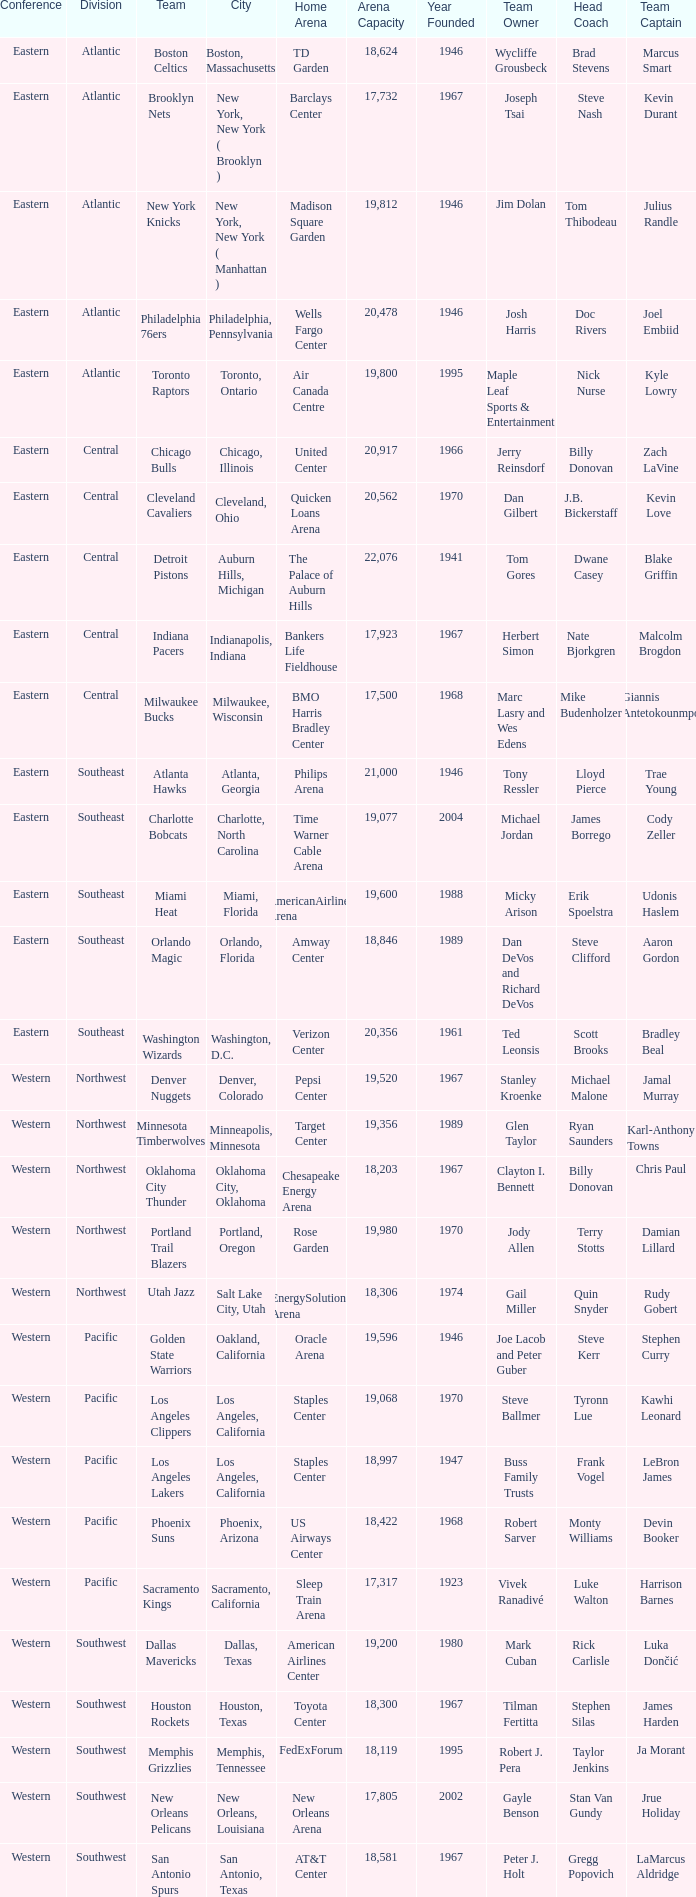Which team is in the Southeast with a home at Philips Arena? Atlanta Hawks. Can you parse all the data within this table? {'header': ['Conference', 'Division', 'Team', 'City', 'Home Arena', 'Arena Capacity', 'Year Founded', 'Team Owner', 'Head Coach', 'Team Captain'], 'rows': [['Eastern', 'Atlantic', 'Boston Celtics', 'Boston, Massachusetts', 'TD Garden', '18,624', '1946', 'Wycliffe Grousbeck', 'Brad Stevens', 'Marcus Smart'], ['Eastern', 'Atlantic', 'Brooklyn Nets', 'New York, New York ( Brooklyn )', 'Barclays Center', '17,732', '1967', 'Joseph Tsai', 'Steve Nash', 'Kevin Durant'], ['Eastern', 'Atlantic', 'New York Knicks', 'New York, New York ( Manhattan )', 'Madison Square Garden', '19,812', '1946', 'Jim Dolan', 'Tom Thibodeau', 'Julius Randle'], ['Eastern', 'Atlantic', 'Philadelphia 76ers', 'Philadelphia, Pennsylvania', 'Wells Fargo Center', '20,478', '1946', 'Josh Harris', 'Doc Rivers', 'Joel Embiid'], ['Eastern', 'Atlantic', 'Toronto Raptors', 'Toronto, Ontario', 'Air Canada Centre', '19,800', '1995', 'Maple Leaf Sports & Entertainment', 'Nick Nurse', 'Kyle Lowry'], ['Eastern', 'Central', 'Chicago Bulls', 'Chicago, Illinois', 'United Center', '20,917', '1966', 'Jerry Reinsdorf', 'Billy Donovan', 'Zach LaVine'], ['Eastern', 'Central', 'Cleveland Cavaliers', 'Cleveland, Ohio', 'Quicken Loans Arena', '20,562', '1970', 'Dan Gilbert', 'J.B. Bickerstaff', 'Kevin Love'], ['Eastern', 'Central', 'Detroit Pistons', 'Auburn Hills, Michigan', 'The Palace of Auburn Hills', '22,076', '1941', 'Tom Gores', 'Dwane Casey', 'Blake Griffin'], ['Eastern', 'Central', 'Indiana Pacers', 'Indianapolis, Indiana', 'Bankers Life Fieldhouse', '17,923', '1967', 'Herbert Simon', 'Nate Bjorkgren', 'Malcolm Brogdon'], ['Eastern', 'Central', 'Milwaukee Bucks', 'Milwaukee, Wisconsin', 'BMO Harris Bradley Center', '17,500', '1968', 'Marc Lasry and Wes Edens', 'Mike Budenholzer', 'Giannis Antetokounmpo'], ['Eastern', 'Southeast', 'Atlanta Hawks', 'Atlanta, Georgia', 'Philips Arena', '21,000', '1946', 'Tony Ressler', 'Lloyd Pierce', 'Trae Young'], ['Eastern', 'Southeast', 'Charlotte Bobcats', 'Charlotte, North Carolina', 'Time Warner Cable Arena', '19,077', '2004', 'Michael Jordan', 'James Borrego', 'Cody Zeller'], ['Eastern', 'Southeast', 'Miami Heat', 'Miami, Florida', 'AmericanAirlines Arena', '19,600', '1988', 'Micky Arison', 'Erik Spoelstra', 'Udonis Haslem'], ['Eastern', 'Southeast', 'Orlando Magic', 'Orlando, Florida', 'Amway Center', '18,846', '1989', 'Dan DeVos and Richard DeVos', 'Steve Clifford', 'Aaron Gordon'], ['Eastern', 'Southeast', 'Washington Wizards', 'Washington, D.C.', 'Verizon Center', '20,356', '1961', 'Ted Leonsis', 'Scott Brooks', 'Bradley Beal'], ['Western', 'Northwest', 'Denver Nuggets', 'Denver, Colorado', 'Pepsi Center', '19,520', '1967', 'Stanley Kroenke', 'Michael Malone', 'Jamal Murray'], ['Western', 'Northwest', 'Minnesota Timberwolves', 'Minneapolis, Minnesota', 'Target Center', '19,356', '1989', 'Glen Taylor', 'Ryan Saunders', 'Karl-Anthony Towns'], ['Western', 'Northwest', 'Oklahoma City Thunder', 'Oklahoma City, Oklahoma', 'Chesapeake Energy Arena', '18,203', '1967', 'Clayton I. Bennett', 'Billy Donovan', 'Chris Paul'], ['Western', 'Northwest', 'Portland Trail Blazers', 'Portland, Oregon', 'Rose Garden', '19,980', '1970', 'Jody Allen', 'Terry Stotts', 'Damian Lillard'], ['Western', 'Northwest', 'Utah Jazz', 'Salt Lake City, Utah', 'EnergySolutions Arena', '18,306', '1974', 'Gail Miller', 'Quin Snyder', 'Rudy Gobert'], ['Western', 'Pacific', 'Golden State Warriors', 'Oakland, California', 'Oracle Arena', '19,596', '1946', 'Joe Lacob and Peter Guber', 'Steve Kerr', 'Stephen Curry'], ['Western', 'Pacific', 'Los Angeles Clippers', 'Los Angeles, California', 'Staples Center', '19,068', '1970', 'Steve Ballmer', 'Tyronn Lue', 'Kawhi Leonard'], ['Western', 'Pacific', 'Los Angeles Lakers', 'Los Angeles, California', 'Staples Center', '18,997', '1947', 'Buss Family Trusts', 'Frank Vogel', 'LeBron James'], ['Western', 'Pacific', 'Phoenix Suns', 'Phoenix, Arizona', 'US Airways Center', '18,422', '1968', 'Robert Sarver', 'Monty Williams', 'Devin Booker'], ['Western', 'Pacific', 'Sacramento Kings', 'Sacramento, California', 'Sleep Train Arena', '17,317', '1923', 'Vivek Ranadivé', 'Luke Walton', 'Harrison Barnes'], ['Western', 'Southwest', 'Dallas Mavericks', 'Dallas, Texas', 'American Airlines Center', '19,200', '1980', 'Mark Cuban', 'Rick Carlisle', 'Luka Dončić'], ['Western', 'Southwest', 'Houston Rockets', 'Houston, Texas', 'Toyota Center', '18,300', '1967', 'Tilman Fertitta', 'Stephen Silas', 'James Harden'], ['Western', 'Southwest', 'Memphis Grizzlies', 'Memphis, Tennessee', 'FedExForum', '18,119', '1995', 'Robert J. Pera', 'Taylor Jenkins', 'Ja Morant'], ['Western', 'Southwest', 'New Orleans Pelicans', 'New Orleans, Louisiana', 'New Orleans Arena', '17,805', '2002', 'Gayle Benson', 'Stan Van Gundy', 'Jrue Holiday'], ['Western', 'Southwest', 'San Antonio Spurs', 'San Antonio, Texas', 'AT&T Center', '18,581', '1967', 'Peter J. Holt', 'Gregg Popovich', 'LaMarcus Aldridge']]} 